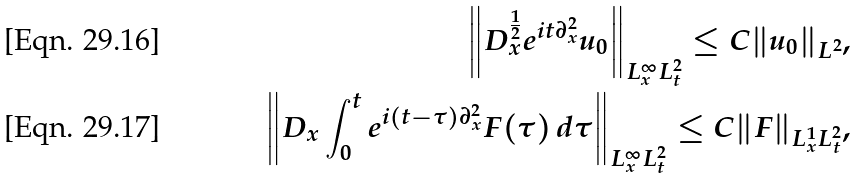Convert formula to latex. <formula><loc_0><loc_0><loc_500><loc_500>\left \| D _ { x } ^ { \frac { 1 } { 2 } } e ^ { i t \partial _ { x } ^ { 2 } } u _ { 0 } \right \| _ { L ^ { \infty } _ { x } L ^ { 2 } _ { t } } \leq C \| u _ { 0 } \| _ { L ^ { 2 } } , \\ \left \| D _ { x } \int _ { 0 } ^ { t } e ^ { i ( t - \tau ) \partial _ { x } ^ { 2 } } F ( \tau ) \, d \tau \right \| _ { L ^ { \infty } _ { x } L ^ { 2 } _ { t } } \leq C \| F \| _ { L ^ { 1 } _ { x } L ^ { 2 } _ { t } } ,</formula> 